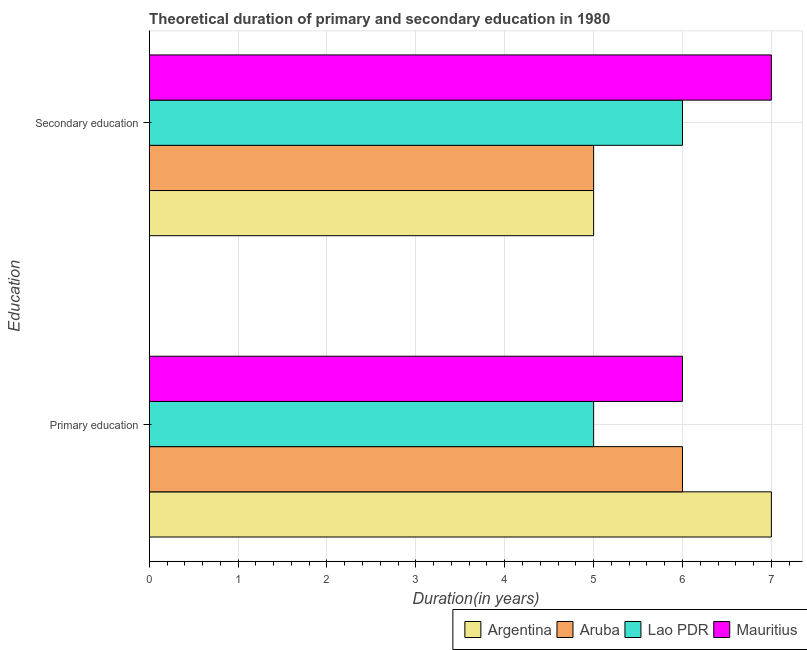How many different coloured bars are there?
Give a very brief answer. 4. How many groups of bars are there?
Your response must be concise. 2. Are the number of bars per tick equal to the number of legend labels?
Offer a very short reply. Yes. Are the number of bars on each tick of the Y-axis equal?
Ensure brevity in your answer.  Yes. How many bars are there on the 1st tick from the bottom?
Your response must be concise. 4. What is the label of the 1st group of bars from the top?
Offer a terse response. Secondary education. What is the duration of secondary education in Aruba?
Offer a terse response. 5. Across all countries, what is the maximum duration of secondary education?
Your answer should be compact. 7. Across all countries, what is the minimum duration of primary education?
Make the answer very short. 5. In which country was the duration of secondary education maximum?
Keep it short and to the point. Mauritius. In which country was the duration of primary education minimum?
Your answer should be compact. Lao PDR. What is the total duration of primary education in the graph?
Your response must be concise. 24. What is the difference between the duration of secondary education in Mauritius and that in Aruba?
Your response must be concise. 2. What is the difference between the duration of primary education in Aruba and the duration of secondary education in Lao PDR?
Your answer should be compact. 0. What is the average duration of primary education per country?
Your answer should be very brief. 6. What is the difference between the duration of primary education and duration of secondary education in Argentina?
Your answer should be compact. 2. In how many countries, is the duration of secondary education greater than 1.2 years?
Give a very brief answer. 4. What is the ratio of the duration of primary education in Aruba to that in Mauritius?
Keep it short and to the point. 1. What does the 2nd bar from the top in Primary education represents?
Your answer should be compact. Lao PDR. What does the 2nd bar from the bottom in Primary education represents?
Provide a short and direct response. Aruba. How many bars are there?
Provide a short and direct response. 8. Are all the bars in the graph horizontal?
Provide a short and direct response. Yes. How many countries are there in the graph?
Offer a terse response. 4. How many legend labels are there?
Your answer should be compact. 4. How are the legend labels stacked?
Provide a short and direct response. Horizontal. What is the title of the graph?
Provide a short and direct response. Theoretical duration of primary and secondary education in 1980. Does "Middle East & North Africa (all income levels)" appear as one of the legend labels in the graph?
Your answer should be compact. No. What is the label or title of the X-axis?
Keep it short and to the point. Duration(in years). What is the label or title of the Y-axis?
Your answer should be very brief. Education. What is the Duration(in years) in Aruba in Primary education?
Offer a terse response. 6. What is the Duration(in years) of Aruba in Secondary education?
Provide a succinct answer. 5. What is the Duration(in years) of Mauritius in Secondary education?
Provide a succinct answer. 7. Across all Education, what is the maximum Duration(in years) in Argentina?
Your answer should be very brief. 7. Across all Education, what is the maximum Duration(in years) of Aruba?
Offer a very short reply. 6. Across all Education, what is the maximum Duration(in years) in Mauritius?
Make the answer very short. 7. Across all Education, what is the minimum Duration(in years) of Argentina?
Your answer should be very brief. 5. Across all Education, what is the minimum Duration(in years) of Aruba?
Your response must be concise. 5. What is the total Duration(in years) of Lao PDR in the graph?
Give a very brief answer. 11. What is the difference between the Duration(in years) of Aruba in Primary education and that in Secondary education?
Offer a terse response. 1. What is the difference between the Duration(in years) in Lao PDR in Primary education and that in Secondary education?
Make the answer very short. -1. What is the difference between the Duration(in years) in Argentina in Primary education and the Duration(in years) in Aruba in Secondary education?
Make the answer very short. 2. What is the difference between the Duration(in years) of Argentina in Primary education and the Duration(in years) of Lao PDR in Secondary education?
Provide a short and direct response. 1. What is the difference between the Duration(in years) in Aruba in Primary education and the Duration(in years) in Mauritius in Secondary education?
Make the answer very short. -1. What is the average Duration(in years) in Aruba per Education?
Keep it short and to the point. 5.5. What is the average Duration(in years) of Mauritius per Education?
Provide a succinct answer. 6.5. What is the difference between the Duration(in years) of Argentina and Duration(in years) of Lao PDR in Primary education?
Ensure brevity in your answer.  2. What is the difference between the Duration(in years) in Argentina and Duration(in years) in Mauritius in Primary education?
Provide a succinct answer. 1. What is the difference between the Duration(in years) in Lao PDR and Duration(in years) in Mauritius in Primary education?
Your answer should be compact. -1. What is the difference between the Duration(in years) in Argentina and Duration(in years) in Aruba in Secondary education?
Your response must be concise. 0. What is the difference between the Duration(in years) in Argentina and Duration(in years) in Mauritius in Secondary education?
Ensure brevity in your answer.  -2. What is the difference between the Duration(in years) of Aruba and Duration(in years) of Lao PDR in Secondary education?
Provide a succinct answer. -1. What is the difference between the Duration(in years) of Lao PDR and Duration(in years) of Mauritius in Secondary education?
Make the answer very short. -1. What is the difference between the highest and the second highest Duration(in years) of Argentina?
Ensure brevity in your answer.  2. What is the difference between the highest and the second highest Duration(in years) of Aruba?
Ensure brevity in your answer.  1. What is the difference between the highest and the lowest Duration(in years) in Argentina?
Offer a terse response. 2. What is the difference between the highest and the lowest Duration(in years) of Aruba?
Your answer should be compact. 1. 